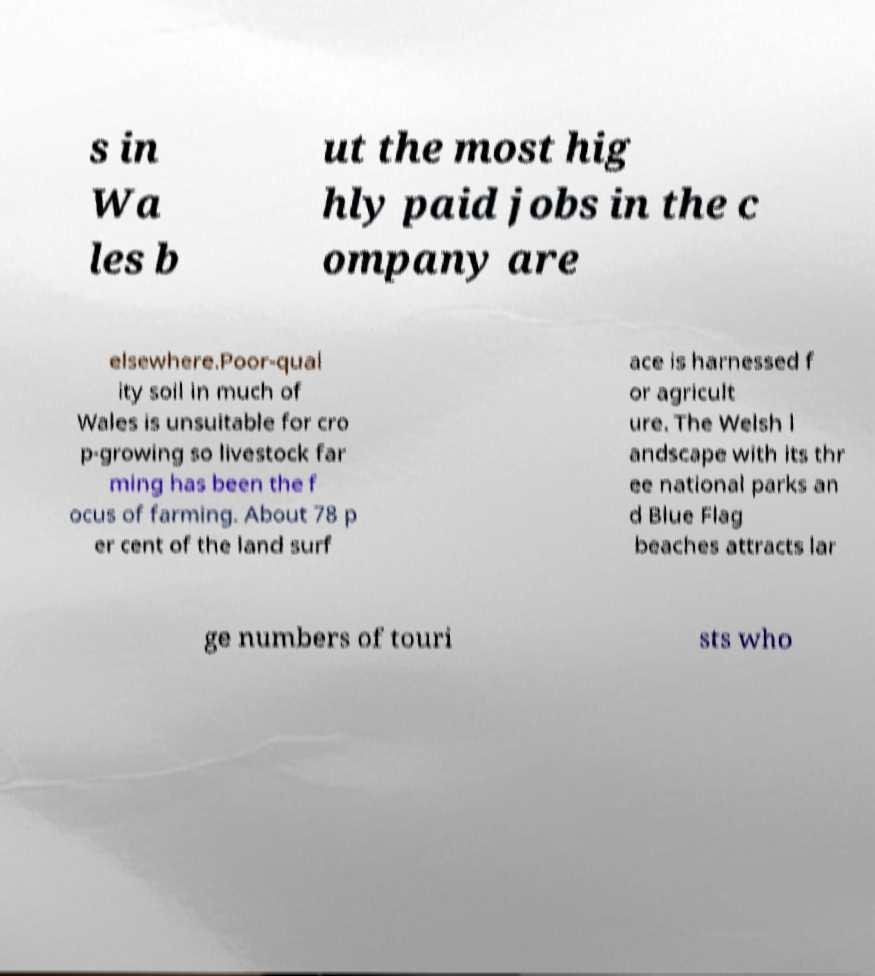Can you read and provide the text displayed in the image?This photo seems to have some interesting text. Can you extract and type it out for me? s in Wa les b ut the most hig hly paid jobs in the c ompany are elsewhere.Poor-qual ity soil in much of Wales is unsuitable for cro p-growing so livestock far ming has been the f ocus of farming. About 78 p er cent of the land surf ace is harnessed f or agricult ure. The Welsh l andscape with its thr ee national parks an d Blue Flag beaches attracts lar ge numbers of touri sts who 